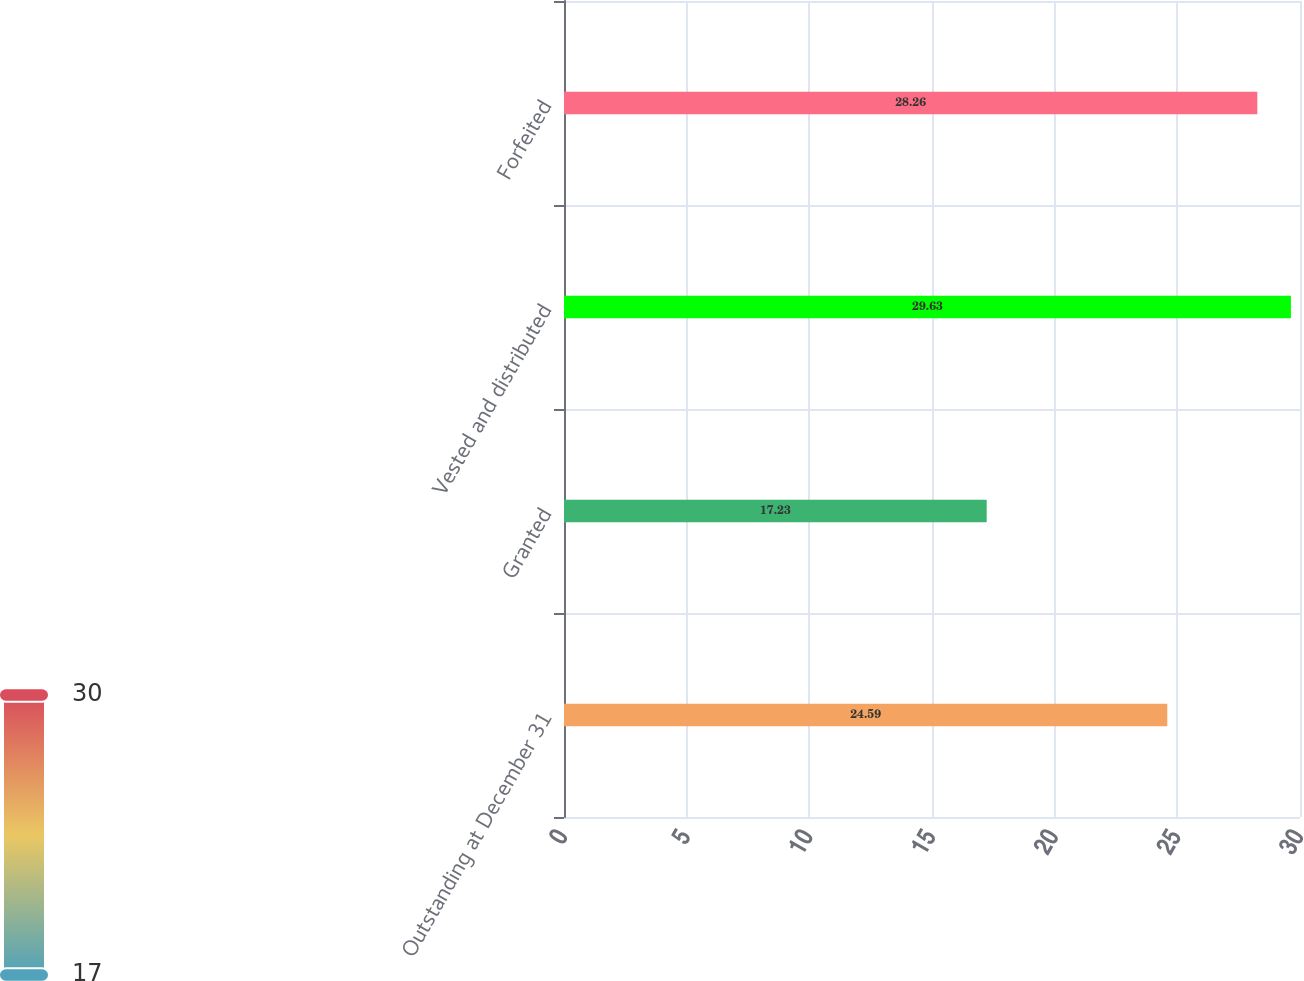Convert chart to OTSL. <chart><loc_0><loc_0><loc_500><loc_500><bar_chart><fcel>Outstanding at December 31<fcel>Granted<fcel>Vested and distributed<fcel>Forfeited<nl><fcel>24.59<fcel>17.23<fcel>29.63<fcel>28.26<nl></chart> 